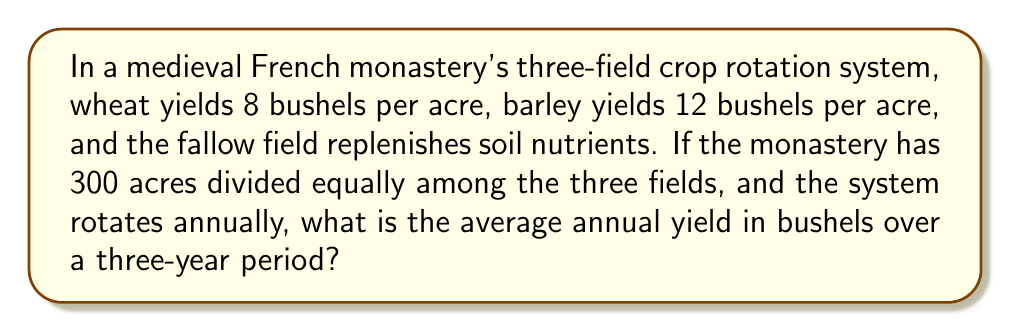Solve this math problem. Let's approach this step-by-step:

1) First, we need to calculate the yield for each year:

   Year 1:
   - Wheat field: $100 \text{ acres} \times 8 \text{ bushels/acre} = 800 \text{ bushels}$
   - Barley field: $100 \text{ acres} \times 12 \text{ bushels/acre} = 1200 \text{ bushels}$
   - Fallow field: 0 bushels
   Total: $800 + 1200 = 2000 \text{ bushels}$

2) For Year 2 and Year 3, the crops rotate, but the yield remains the same:
   Year 2: 2000 bushels
   Year 3: 2000 bushels

3) To calculate the average annual yield over three years:

   $$\text{Average Annual Yield} = \frac{\text{Total Yield over 3 years}}{\text{Number of years}}$$

   $$= \frac{2000 + 2000 + 2000}{3} = \frac{6000}{3} = 2000 \text{ bushels}$$

Therefore, the average annual yield over a three-year period is 2000 bushels.
Answer: 2000 bushels 